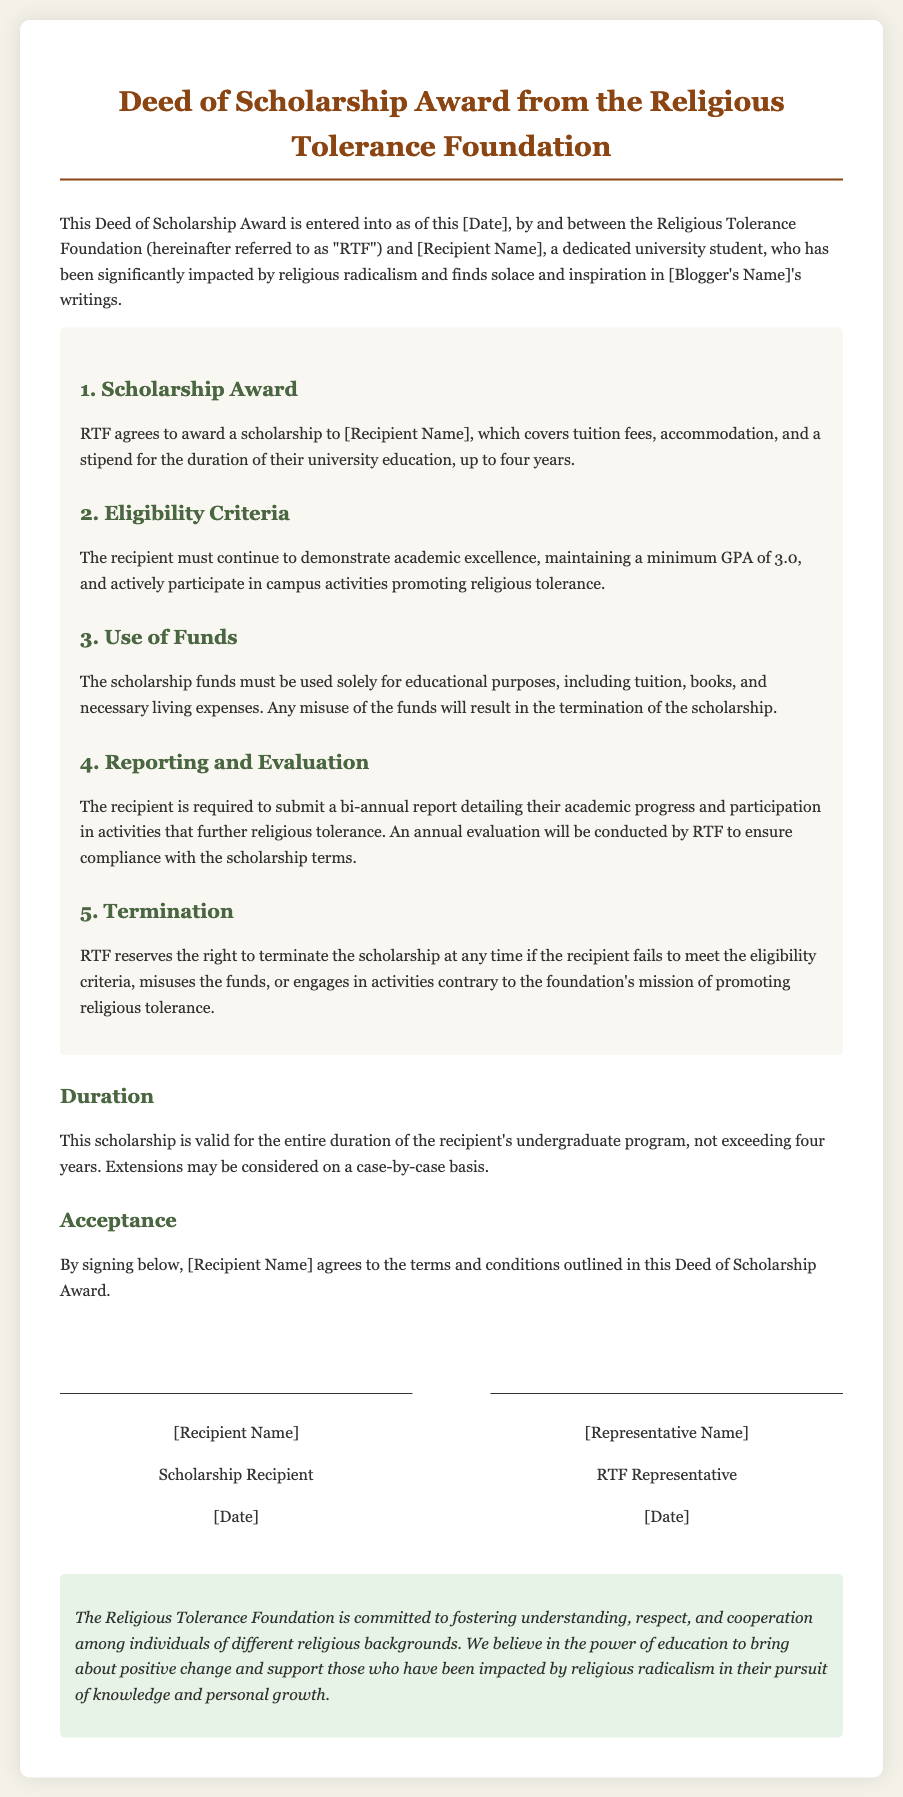What is the name of the foundation providing the scholarship? The foundation providing the scholarship is explicitly named in the document as the "Religious Tolerance Foundation."
Answer: Religious Tolerance Foundation What is the maximum duration of the scholarship? The document states that the scholarship is valid for the entire duration of the recipient's undergraduate program, not exceeding four years.
Answer: four years What is the minimum GPA the recipient must maintain? The eligibility criteria require the recipient to maintain a minimum GPA for continued scholarship eligibility.
Answer: 3.0 What must the scholarship funds be used for? The document specifies that the scholarship funds are to be used solely for educational purposes, which include tuition, books, and necessary living expenses.
Answer: educational purposes What is the consequence of misusing the scholarship funds? The document indicates that any misuse of the funds will result in the termination of the scholarship.
Answer: termination What type of report must the recipient submit bi-annually? The recipient is required to submit a report detailing their academic progress and participation in activities that further religious tolerance.
Answer: academic progress report What actions can lead to the termination of the scholarship? The document provides conditions under which the scholarship may be terminated, including failing to meet eligibility criteria or engaging in contrary activities.
Answer: failing to meet eligibility criteria What does RTF stand for in the context of this document? In the context of this document, RTF is an acronym representing the “Religious Tolerance Foundation.”
Answer: Religious Tolerance Foundation What agreement is made when the recipient signs the document? By signing the document, the recipient agrees to the terms and conditions outlined in this Deed of Scholarship Award.
Answer: terms and conditions 